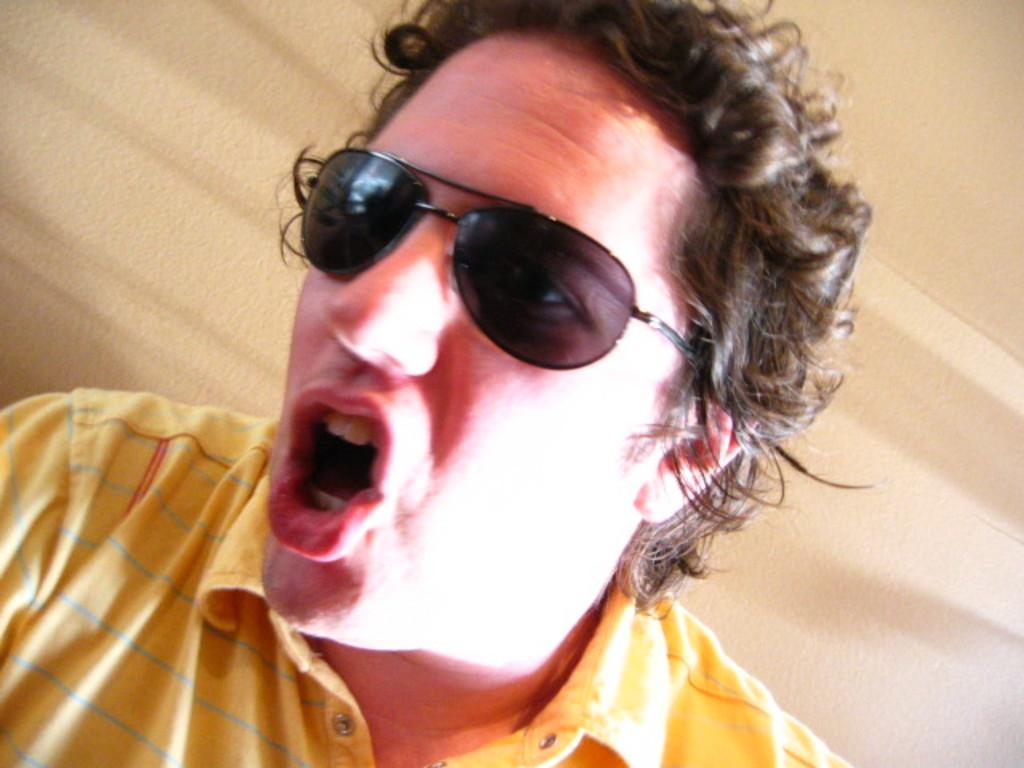Could you give a brief overview of what you see in this image? In this image we can see this person wearing yellow T-shirt and glasses has opened his mouth. In the background, we can see a wall which is in cream color. 